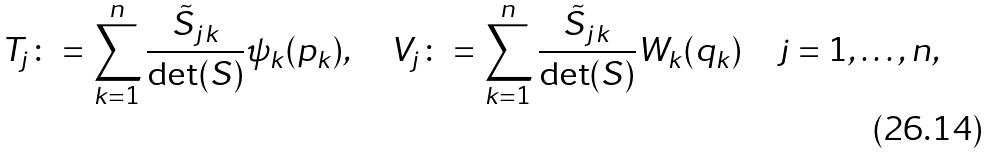<formula> <loc_0><loc_0><loc_500><loc_500>T _ { j } \colon = \sum _ { k = 1 } ^ { n } \frac { \tilde { S } _ { j k } } { \det ( S ) } \psi _ { k } ( p _ { k } ) , \quad V _ { j } \colon = \sum _ { k = 1 } ^ { n } \frac { \tilde { S } _ { j k } } { \det ( S ) } W _ { k } ( q _ { k } ) \quad j = 1 , \dots , n ,</formula> 